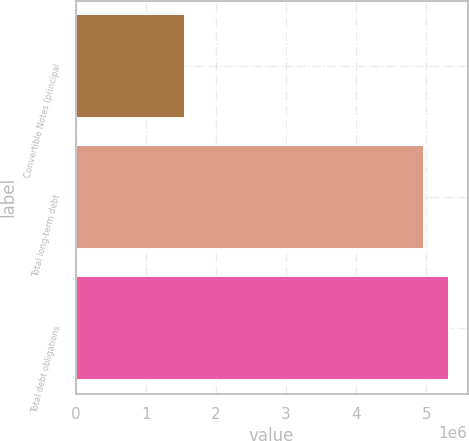<chart> <loc_0><loc_0><loc_500><loc_500><bar_chart><fcel>Convertible Notes (principal<fcel>Total long-term debt<fcel>Total debt obligations<nl><fcel>1.55866e+06<fcel>4.97118e+06<fcel>5.31887e+06<nl></chart> 